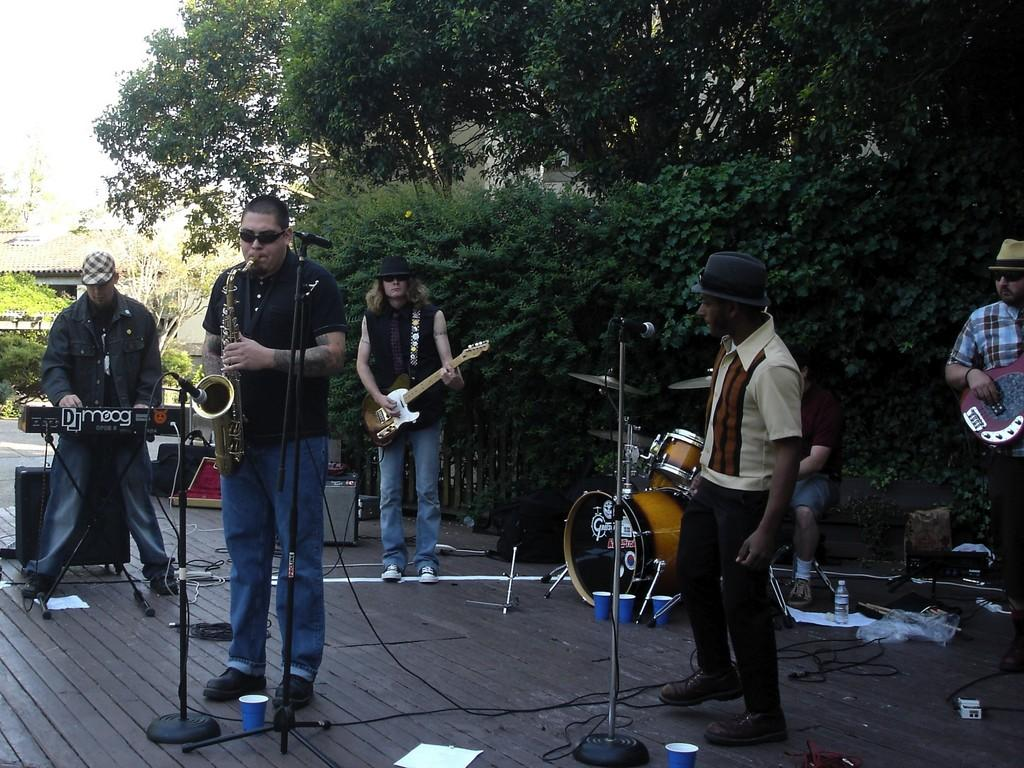What are the people in the image doing? The people in the image are playing musical instruments. What can be seen in the background of the image? There are trees and the sky visible in the background of the image. How many sisters are playing musical instruments in the image? There is no mention of sisters in the image, and the number of people playing musical instruments is not specified. 